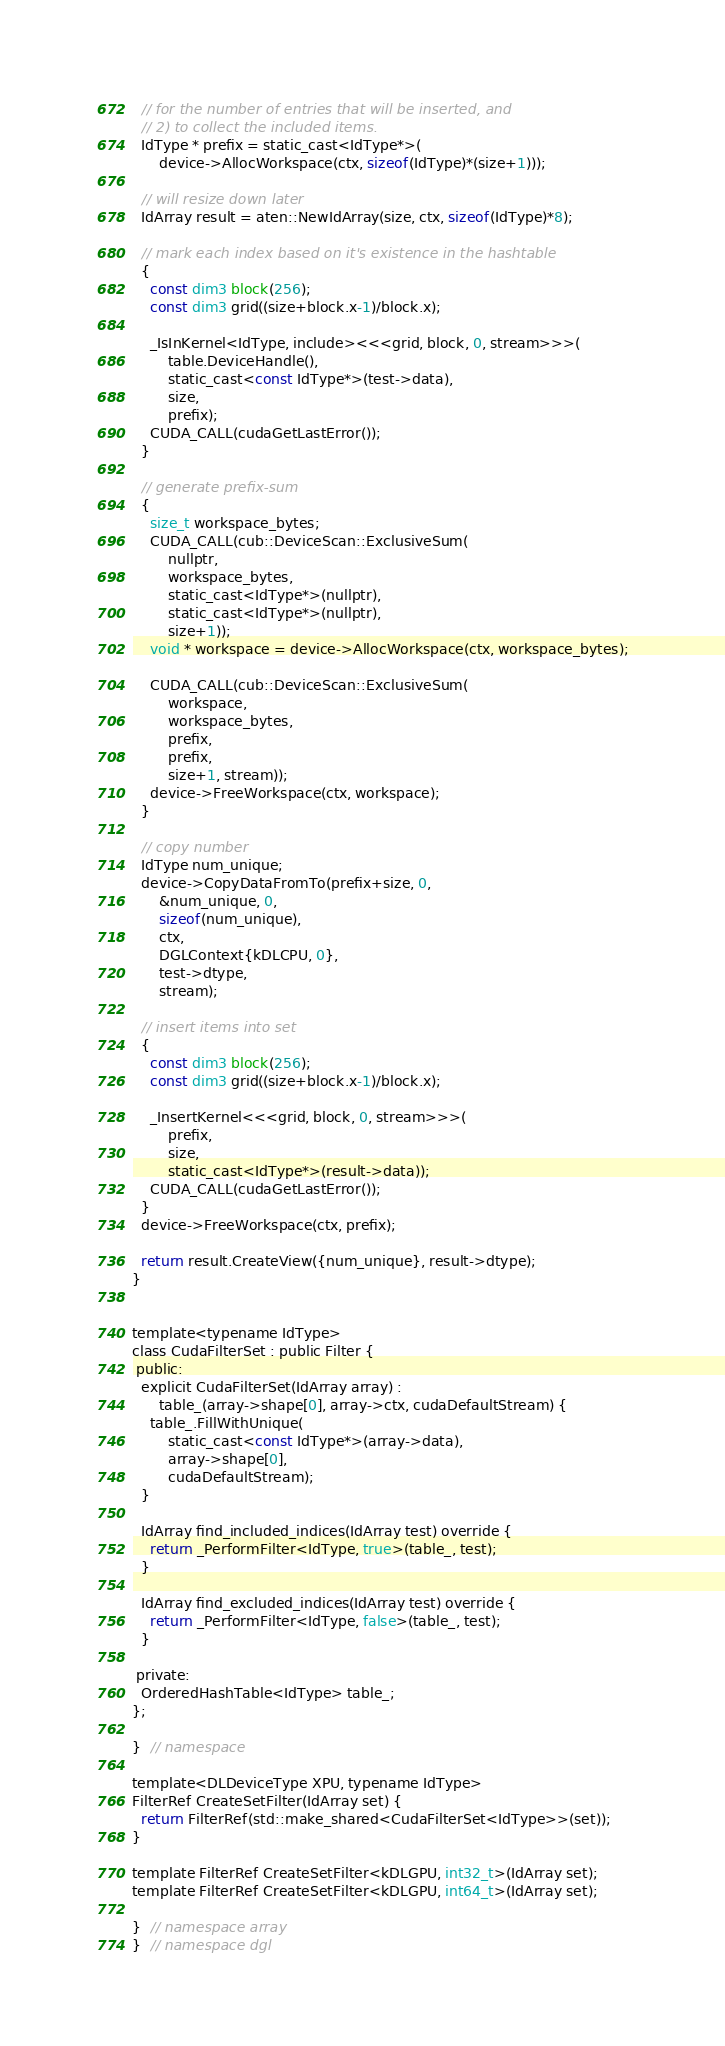Convert code to text. <code><loc_0><loc_0><loc_500><loc_500><_Cuda_>  // for the number of entries that will be inserted, and
  // 2) to collect the included items.
  IdType * prefix = static_cast<IdType*>(
      device->AllocWorkspace(ctx, sizeof(IdType)*(size+1)));

  // will resize down later
  IdArray result = aten::NewIdArray(size, ctx, sizeof(IdType)*8);

  // mark each index based on it's existence in the hashtable
  {
    const dim3 block(256);
    const dim3 grid((size+block.x-1)/block.x);

    _IsInKernel<IdType, include><<<grid, block, 0, stream>>>(
        table.DeviceHandle(),
        static_cast<const IdType*>(test->data),
        size,
        prefix);
    CUDA_CALL(cudaGetLastError());
  }

  // generate prefix-sum
  {
    size_t workspace_bytes;
    CUDA_CALL(cub::DeviceScan::ExclusiveSum(
        nullptr,
        workspace_bytes,
        static_cast<IdType*>(nullptr),
        static_cast<IdType*>(nullptr),
        size+1));
    void * workspace = device->AllocWorkspace(ctx, workspace_bytes);

    CUDA_CALL(cub::DeviceScan::ExclusiveSum(
        workspace,
        workspace_bytes,
        prefix,
        prefix,
        size+1, stream));
    device->FreeWorkspace(ctx, workspace);
  }

  // copy number
  IdType num_unique;
  device->CopyDataFromTo(prefix+size, 0,
      &num_unique, 0,
      sizeof(num_unique),
      ctx,
      DGLContext{kDLCPU, 0},
      test->dtype,
      stream);

  // insert items into set
  {
    const dim3 block(256);
    const dim3 grid((size+block.x-1)/block.x);

    _InsertKernel<<<grid, block, 0, stream>>>(
        prefix,
        size,
        static_cast<IdType*>(result->data));
    CUDA_CALL(cudaGetLastError());
  }
  device->FreeWorkspace(ctx, prefix);

  return result.CreateView({num_unique}, result->dtype);
}


template<typename IdType>
class CudaFilterSet : public Filter {
 public:
  explicit CudaFilterSet(IdArray array) :
      table_(array->shape[0], array->ctx, cudaDefaultStream) {
    table_.FillWithUnique(
        static_cast<const IdType*>(array->data),
        array->shape[0],
        cudaDefaultStream);
  }

  IdArray find_included_indices(IdArray test) override {
    return _PerformFilter<IdType, true>(table_, test);
  }

  IdArray find_excluded_indices(IdArray test) override {
    return _PerformFilter<IdType, false>(table_, test);
  }

 private:
  OrderedHashTable<IdType> table_;
};

}  // namespace

template<DLDeviceType XPU, typename IdType>
FilterRef CreateSetFilter(IdArray set) {
  return FilterRef(std::make_shared<CudaFilterSet<IdType>>(set));
}

template FilterRef CreateSetFilter<kDLGPU, int32_t>(IdArray set);
template FilterRef CreateSetFilter<kDLGPU, int64_t>(IdArray set);

}  // namespace array
}  // namespace dgl
</code> 